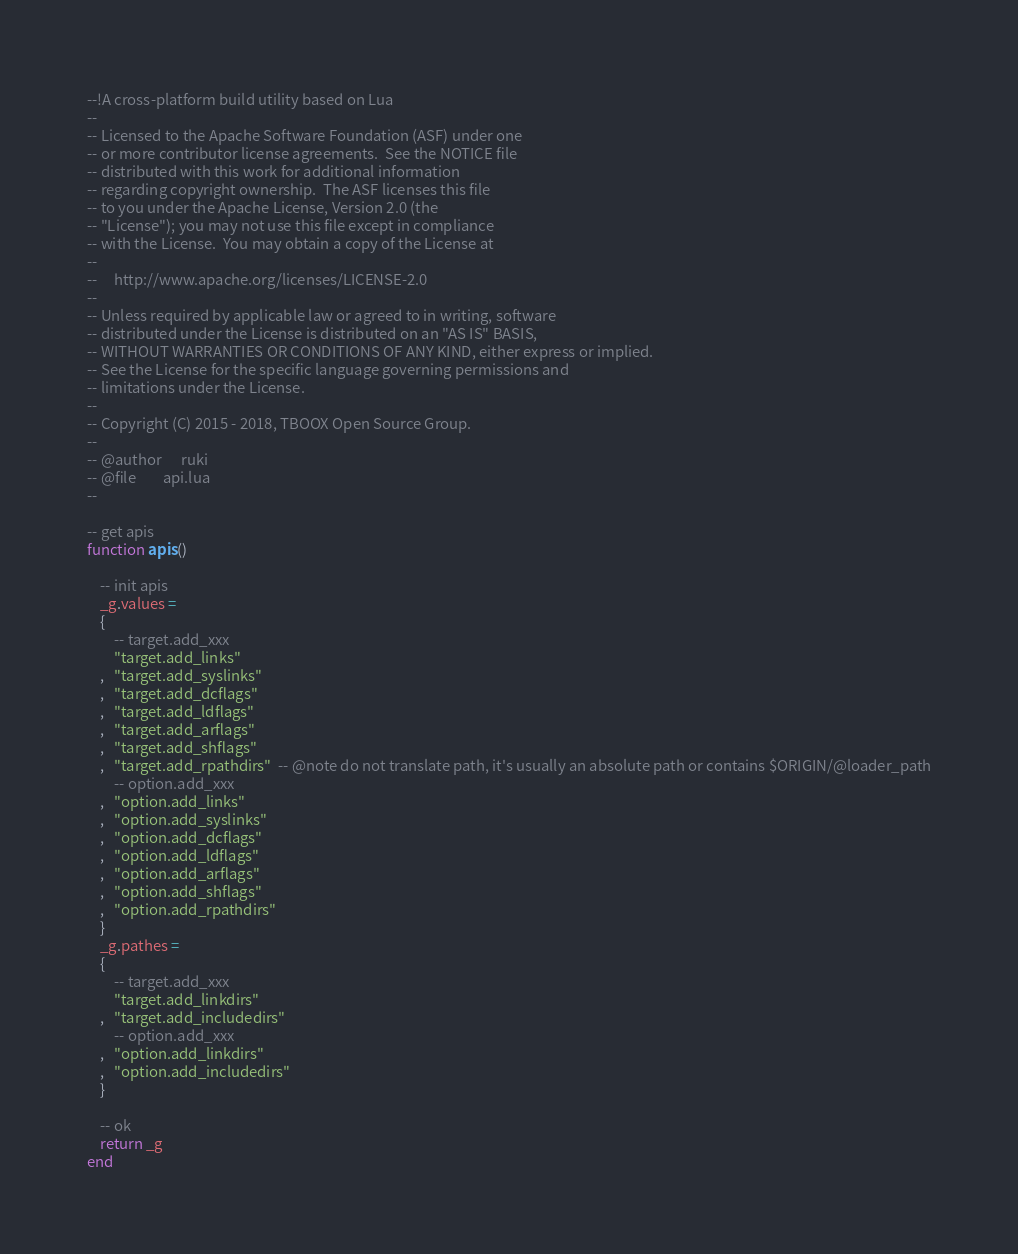<code> <loc_0><loc_0><loc_500><loc_500><_Lua_>--!A cross-platform build utility based on Lua
--
-- Licensed to the Apache Software Foundation (ASF) under one
-- or more contributor license agreements.  See the NOTICE file
-- distributed with this work for additional information
-- regarding copyright ownership.  The ASF licenses this file
-- to you under the Apache License, Version 2.0 (the
-- "License"); you may not use this file except in compliance
-- with the License.  You may obtain a copy of the License at
--
--     http://www.apache.org/licenses/LICENSE-2.0
--
-- Unless required by applicable law or agreed to in writing, software
-- distributed under the License is distributed on an "AS IS" BASIS,
-- WITHOUT WARRANTIES OR CONDITIONS OF ANY KIND, either express or implied.
-- See the License for the specific language governing permissions and
-- limitations under the License.
-- 
-- Copyright (C) 2015 - 2018, TBOOX Open Source Group.
--
-- @author      ruki
-- @file        api.lua
--

-- get apis
function apis()

    -- init apis
    _g.values = 
    {
        -- target.add_xxx
        "target.add_links"
    ,   "target.add_syslinks"
    ,   "target.add_dcflags"
    ,   "target.add_ldflags"
    ,   "target.add_arflags"
    ,   "target.add_shflags"
    ,   "target.add_rpathdirs"  -- @note do not translate path, it's usually an absolute path or contains $ORIGIN/@loader_path
        -- option.add_xxx
    ,   "option.add_links"
    ,   "option.add_syslinks"
    ,   "option.add_dcflags"
    ,   "option.add_ldflags"
    ,   "option.add_arflags"
    ,   "option.add_shflags"
    ,   "option.add_rpathdirs"
    }
    _g.pathes = 
    {
        -- target.add_xxx
        "target.add_linkdirs"
    ,   "target.add_includedirs"
        -- option.add_xxx
    ,   "option.add_linkdirs"
    ,   "option.add_includedirs"
    }

    -- ok
    return _g
end


</code> 